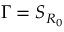Convert formula to latex. <formula><loc_0><loc_0><loc_500><loc_500>\Gamma = S _ { R _ { 0 } }</formula> 